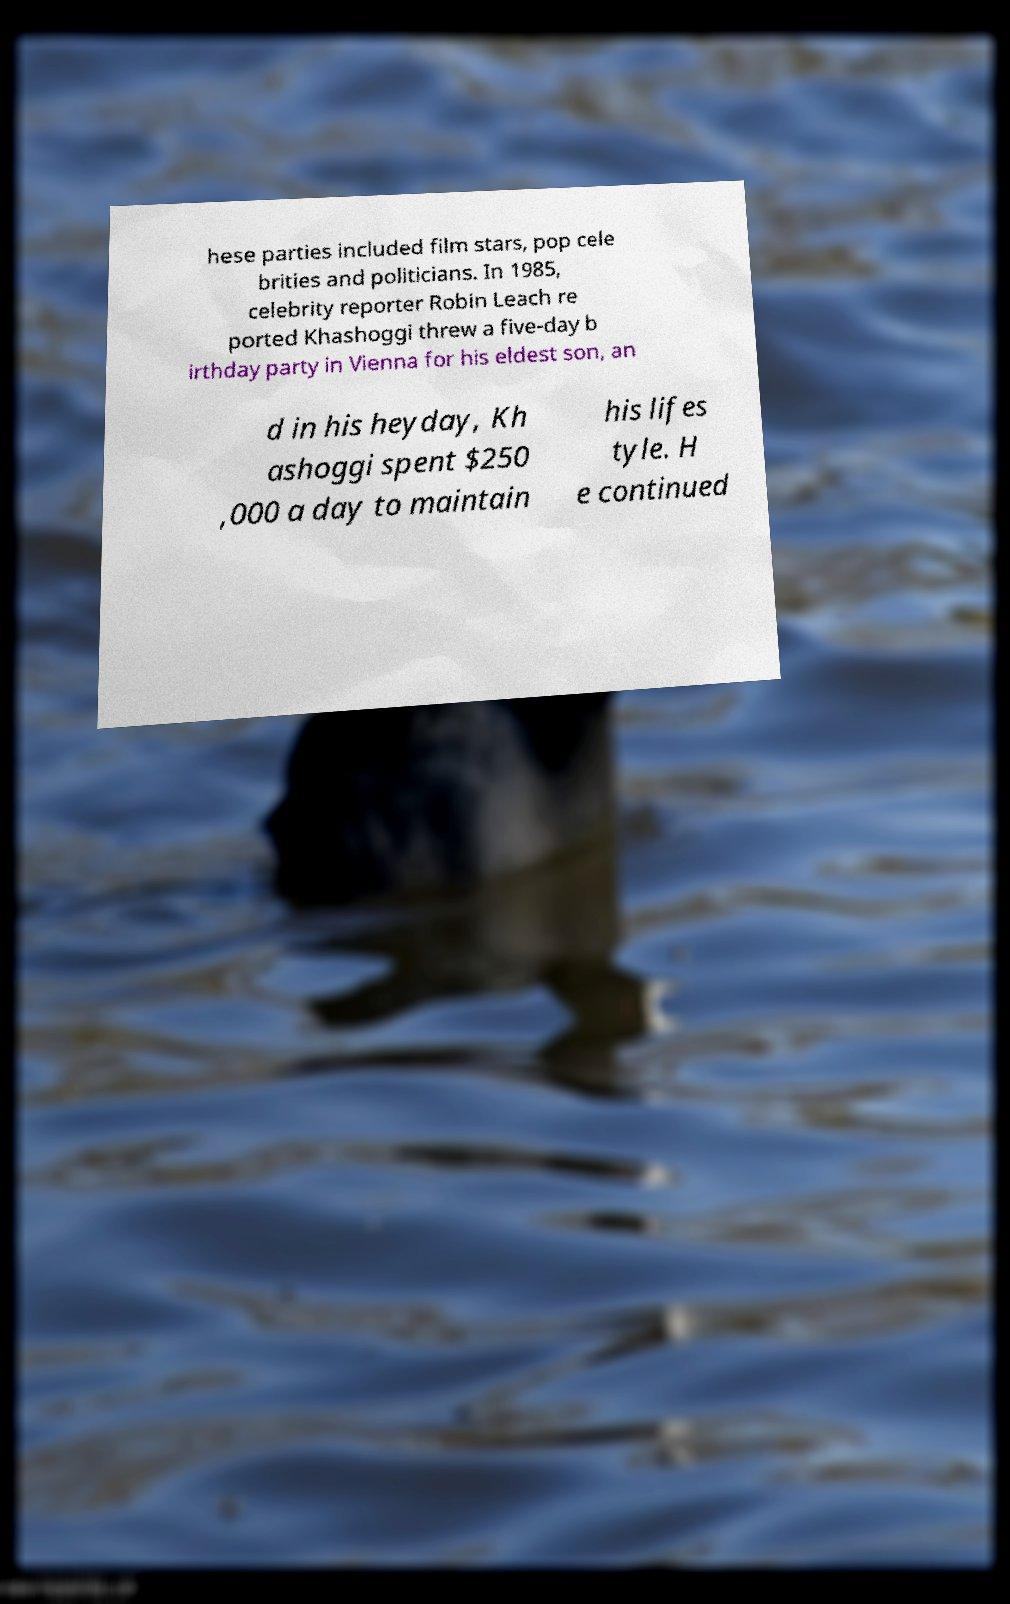For documentation purposes, I need the text within this image transcribed. Could you provide that? hese parties included film stars, pop cele brities and politicians. In 1985, celebrity reporter Robin Leach re ported Khashoggi threw a five-day b irthday party in Vienna for his eldest son, an d in his heyday, Kh ashoggi spent $250 ,000 a day to maintain his lifes tyle. H e continued 